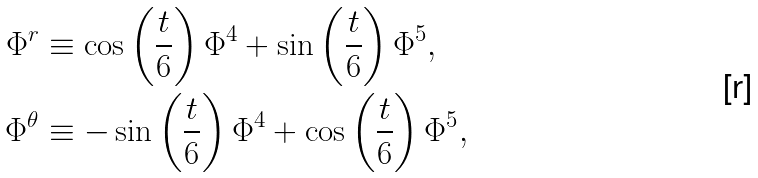Convert formula to latex. <formula><loc_0><loc_0><loc_500><loc_500>\Phi ^ { r } & \equiv \cos \left ( \frac { t } { 6 } \right ) \Phi ^ { 4 } + \sin \left ( \frac { t } { 6 } \right ) \Phi ^ { 5 } , \\ \Phi ^ { \theta } & \equiv - \sin \left ( \frac { t } { 6 } \right ) \Phi ^ { 4 } + \cos \left ( \frac { t } { 6 } \right ) \Phi ^ { 5 } ,</formula> 